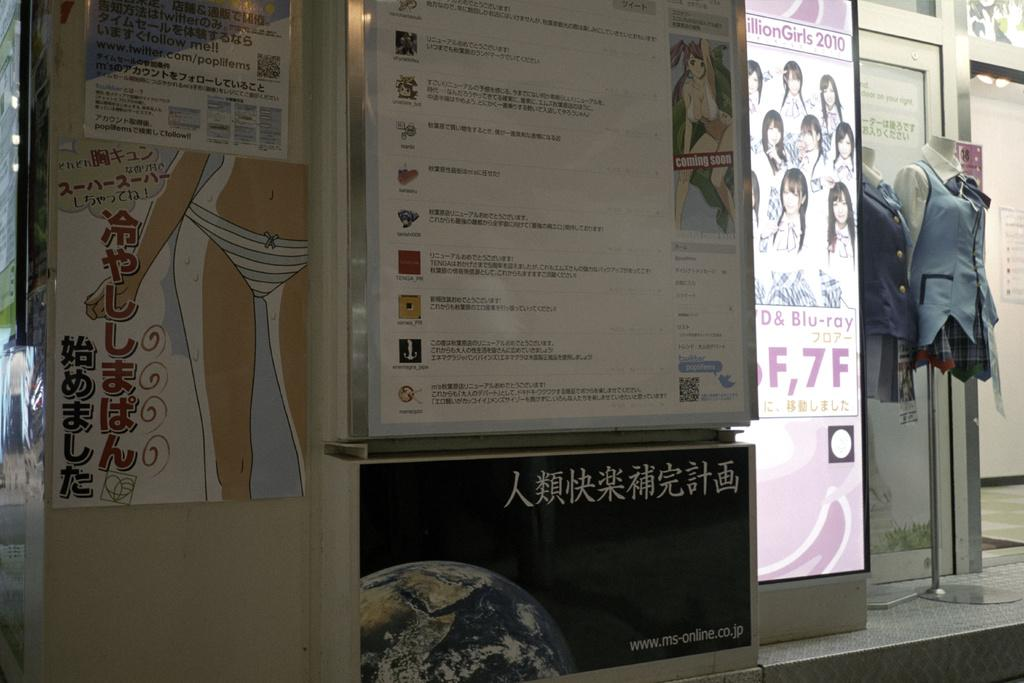What type of establishment is depicted in the image? There is a store in the image. What can be seen on the store's exterior? There are posters on the store. What is being displayed in the store? There are mannequins with clothes in the image. What is the purpose of the mannequins in the store? The mannequins are used for display purposes. What color is the dad's toe in the image? There is no dad or toe present in the image. 